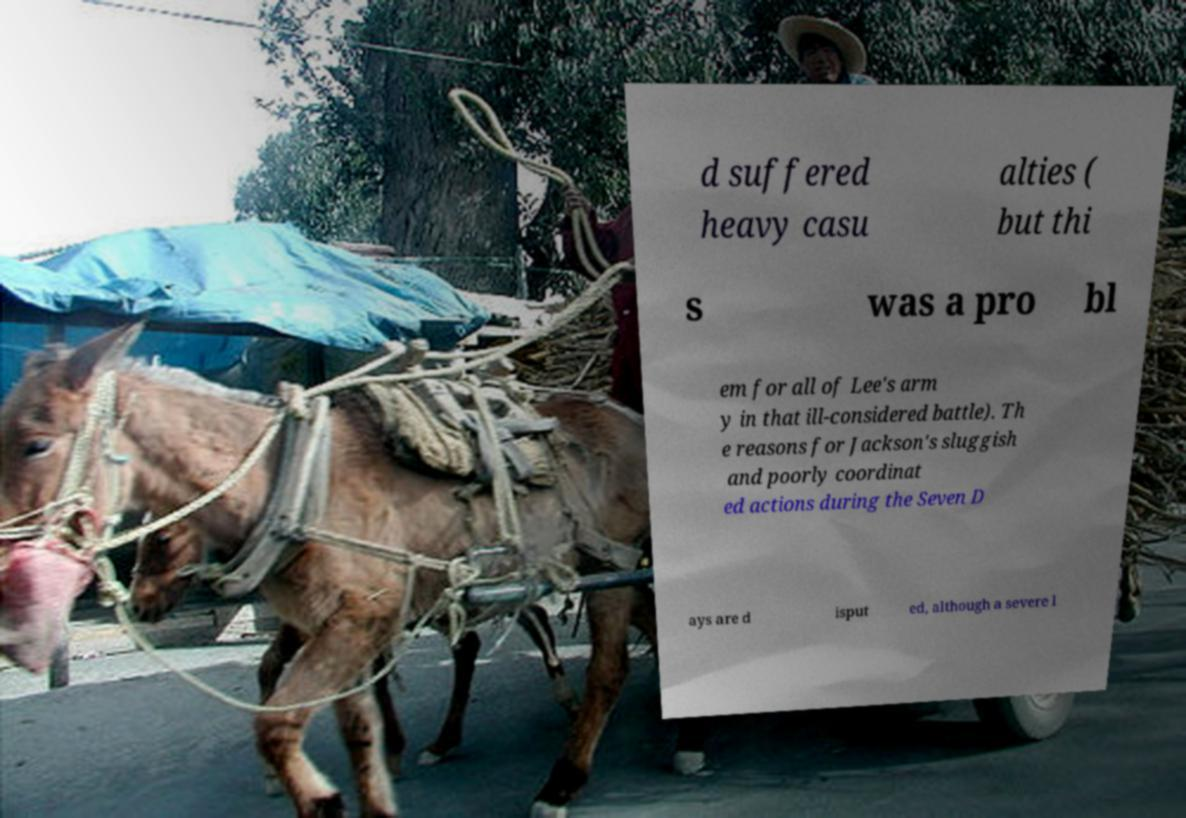Could you extract and type out the text from this image? d suffered heavy casu alties ( but thi s was a pro bl em for all of Lee's arm y in that ill-considered battle). Th e reasons for Jackson's sluggish and poorly coordinat ed actions during the Seven D ays are d isput ed, although a severe l 